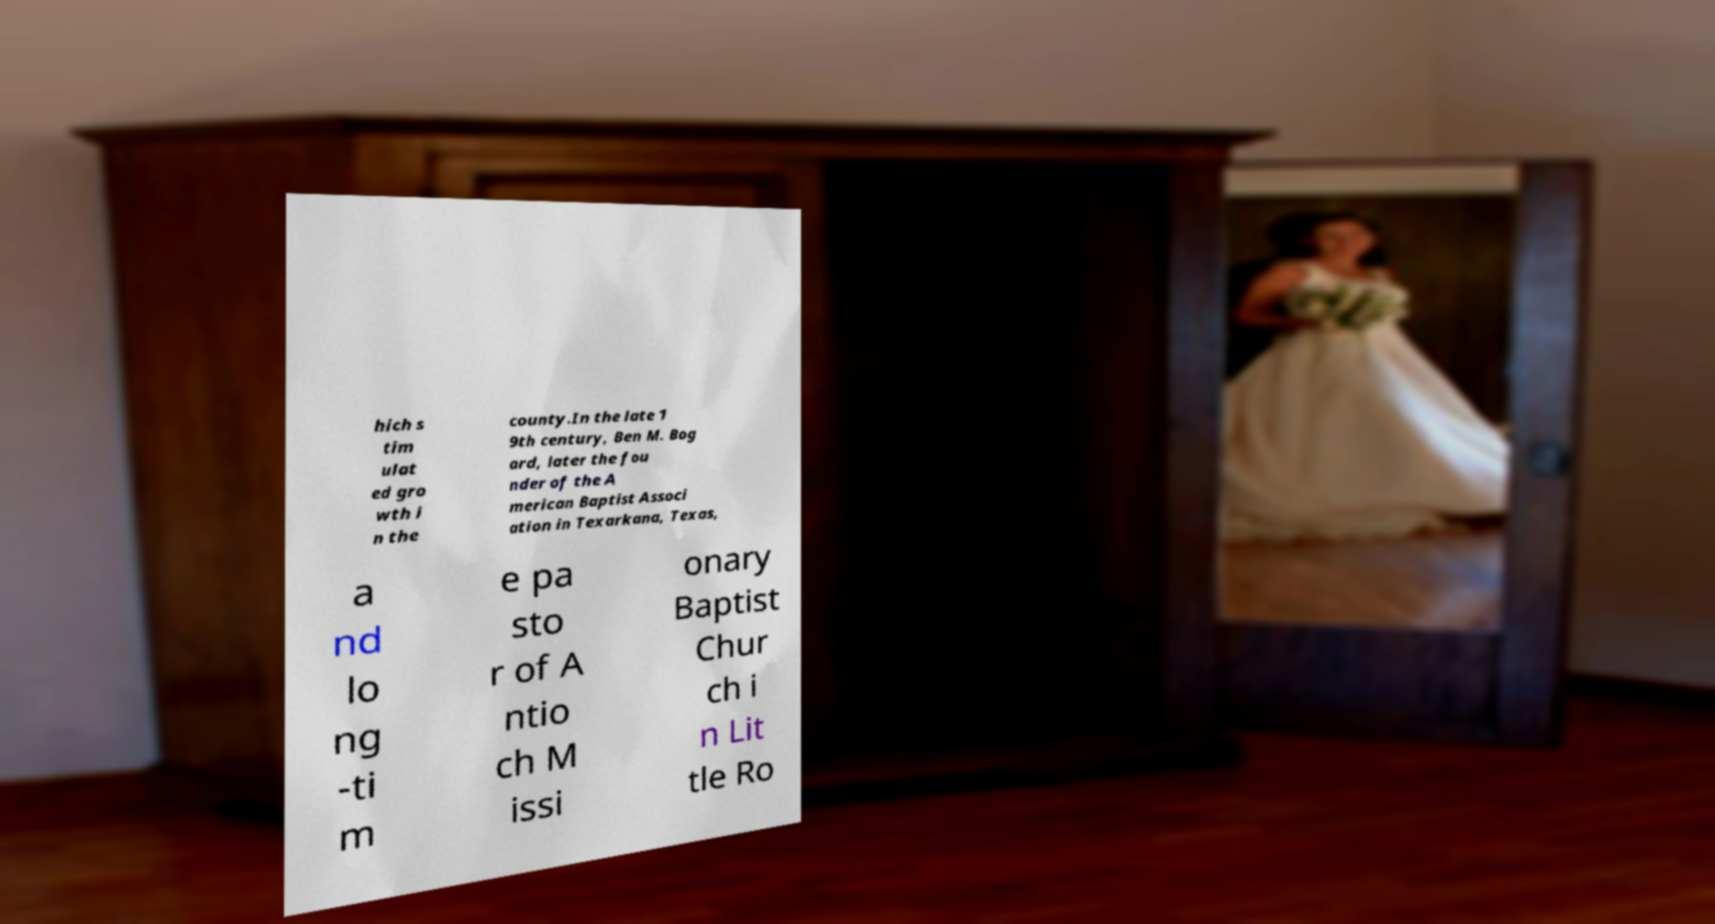Can you read and provide the text displayed in the image?This photo seems to have some interesting text. Can you extract and type it out for me? hich s tim ulat ed gro wth i n the county.In the late 1 9th century, Ben M. Bog ard, later the fou nder of the A merican Baptist Associ ation in Texarkana, Texas, a nd lo ng -ti m e pa sto r of A ntio ch M issi onary Baptist Chur ch i n Lit tle Ro 